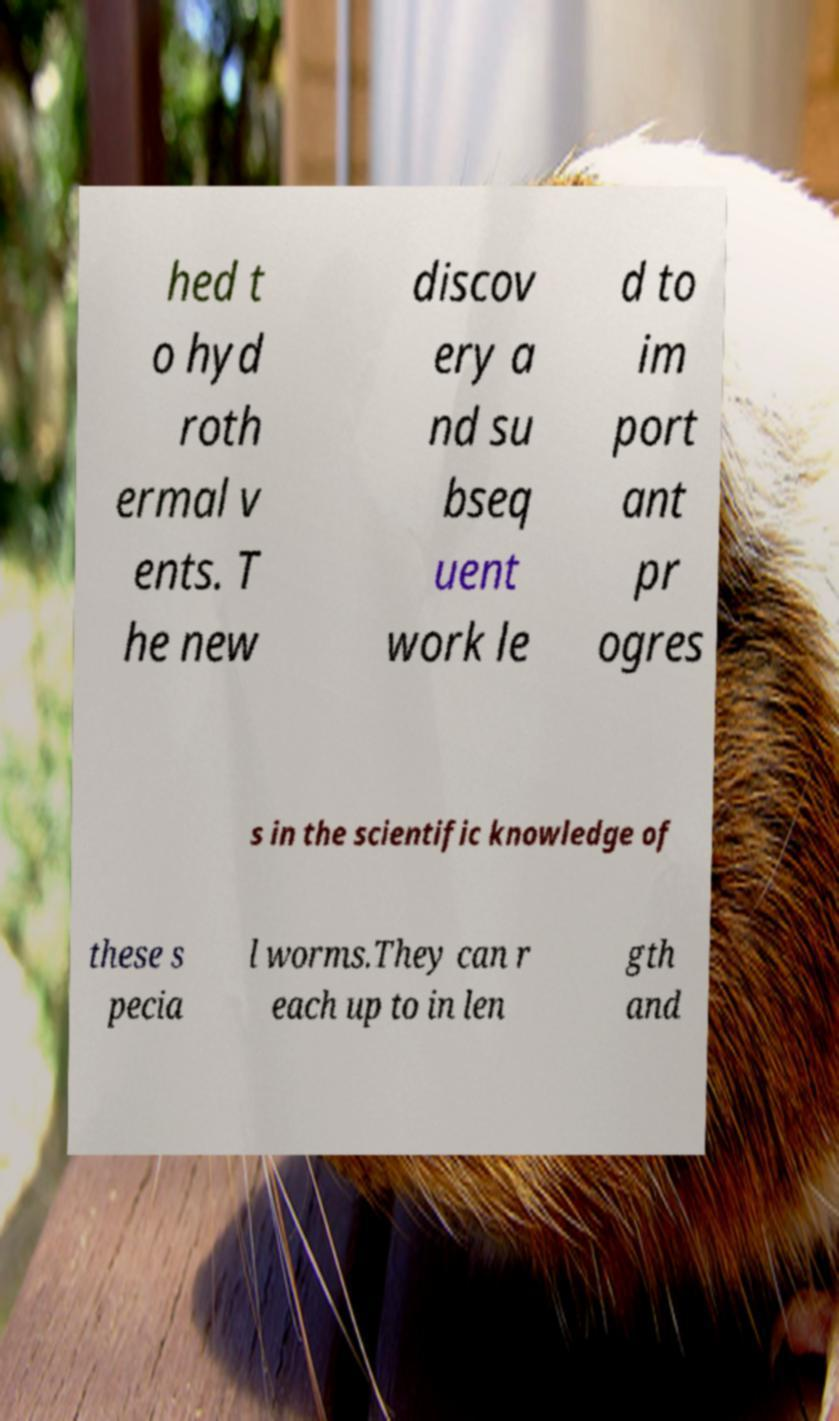Can you accurately transcribe the text from the provided image for me? hed t o hyd roth ermal v ents. T he new discov ery a nd su bseq uent work le d to im port ant pr ogres s in the scientific knowledge of these s pecia l worms.They can r each up to in len gth and 